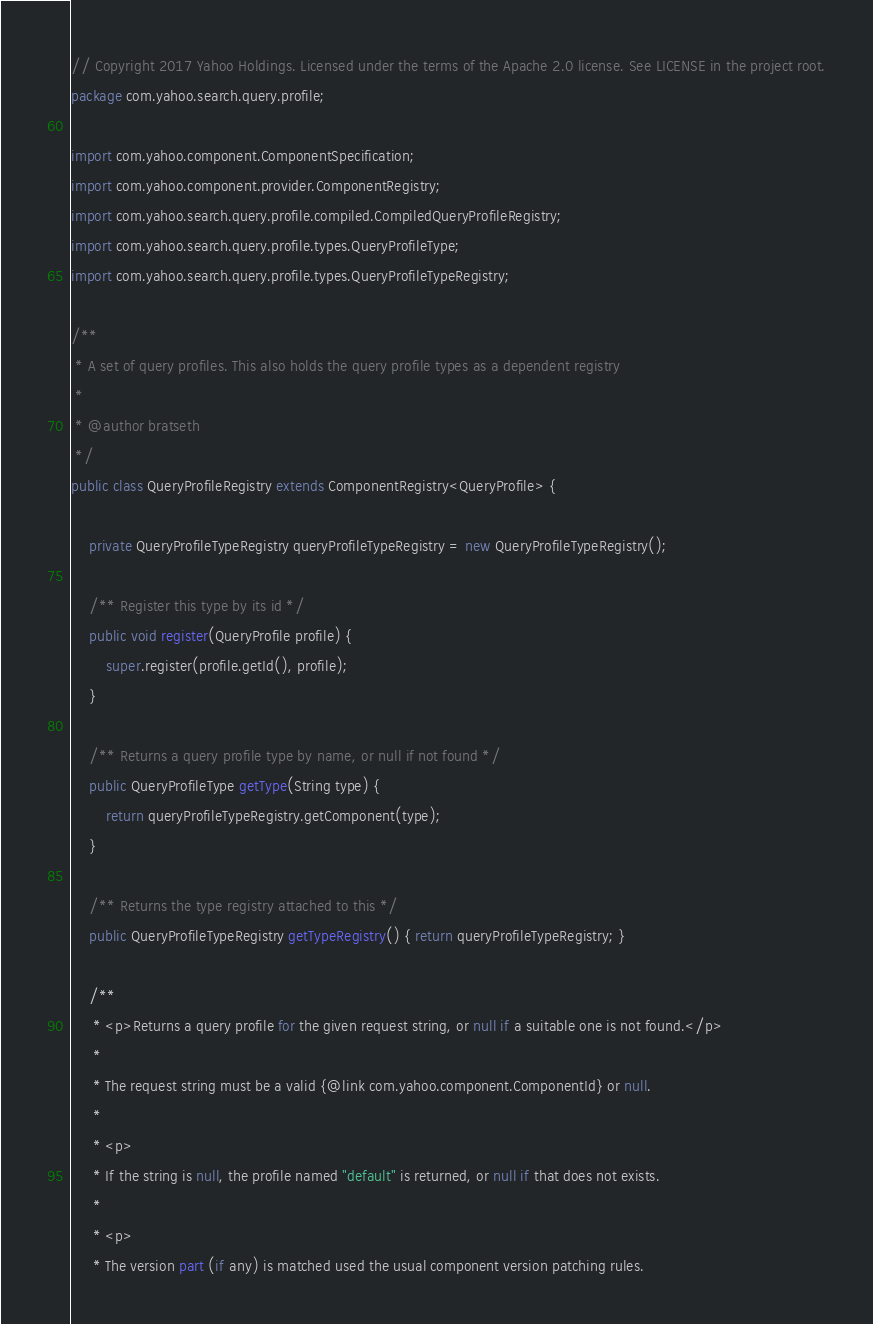<code> <loc_0><loc_0><loc_500><loc_500><_Java_>// Copyright 2017 Yahoo Holdings. Licensed under the terms of the Apache 2.0 license. See LICENSE in the project root.
package com.yahoo.search.query.profile;

import com.yahoo.component.ComponentSpecification;
import com.yahoo.component.provider.ComponentRegistry;
import com.yahoo.search.query.profile.compiled.CompiledQueryProfileRegistry;
import com.yahoo.search.query.profile.types.QueryProfileType;
import com.yahoo.search.query.profile.types.QueryProfileTypeRegistry;

/**
 * A set of query profiles. This also holds the query profile types as a dependent registry
 *
 * @author bratseth
 */
public class QueryProfileRegistry extends ComponentRegistry<QueryProfile> {

    private QueryProfileTypeRegistry queryProfileTypeRegistry = new QueryProfileTypeRegistry();

    /** Register this type by its id */
    public void register(QueryProfile profile) {
        super.register(profile.getId(), profile);
    }

    /** Returns a query profile type by name, or null if not found */
    public QueryProfileType getType(String type) {
        return queryProfileTypeRegistry.getComponent(type);
    }

    /** Returns the type registry attached to this */
    public QueryProfileTypeRegistry getTypeRegistry() { return queryProfileTypeRegistry; }

    /**
     * <p>Returns a query profile for the given request string, or null if a suitable one is not found.</p>
     *
     * The request string must be a valid {@link com.yahoo.component.ComponentId} or null.
     *
     * <p>
     * If the string is null, the profile named "default" is returned, or null if that does not exists.
     *
     * <p>
     * The version part (if any) is matched used the usual component version patching rules.</code> 